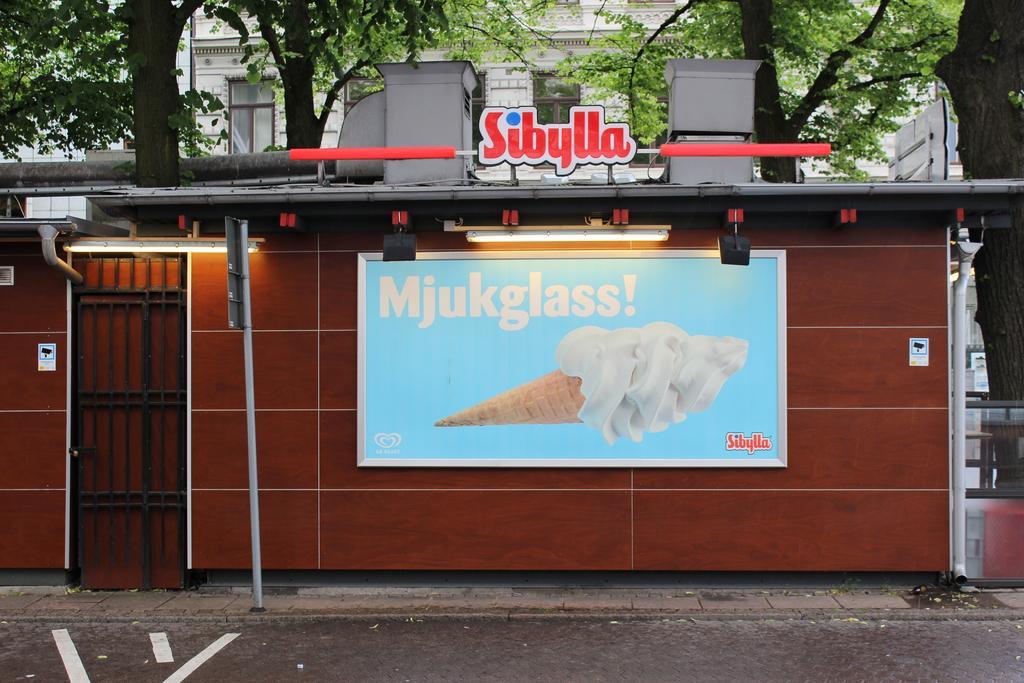Could you give a brief overview of what you see in this image? In the middle of this image there is a shed. Here I can see a board and two lights. On the left side there is a metal frame. At the bottom there is a road. In the background there are many trees and a building. At the top of this shed there is some text in red color. 